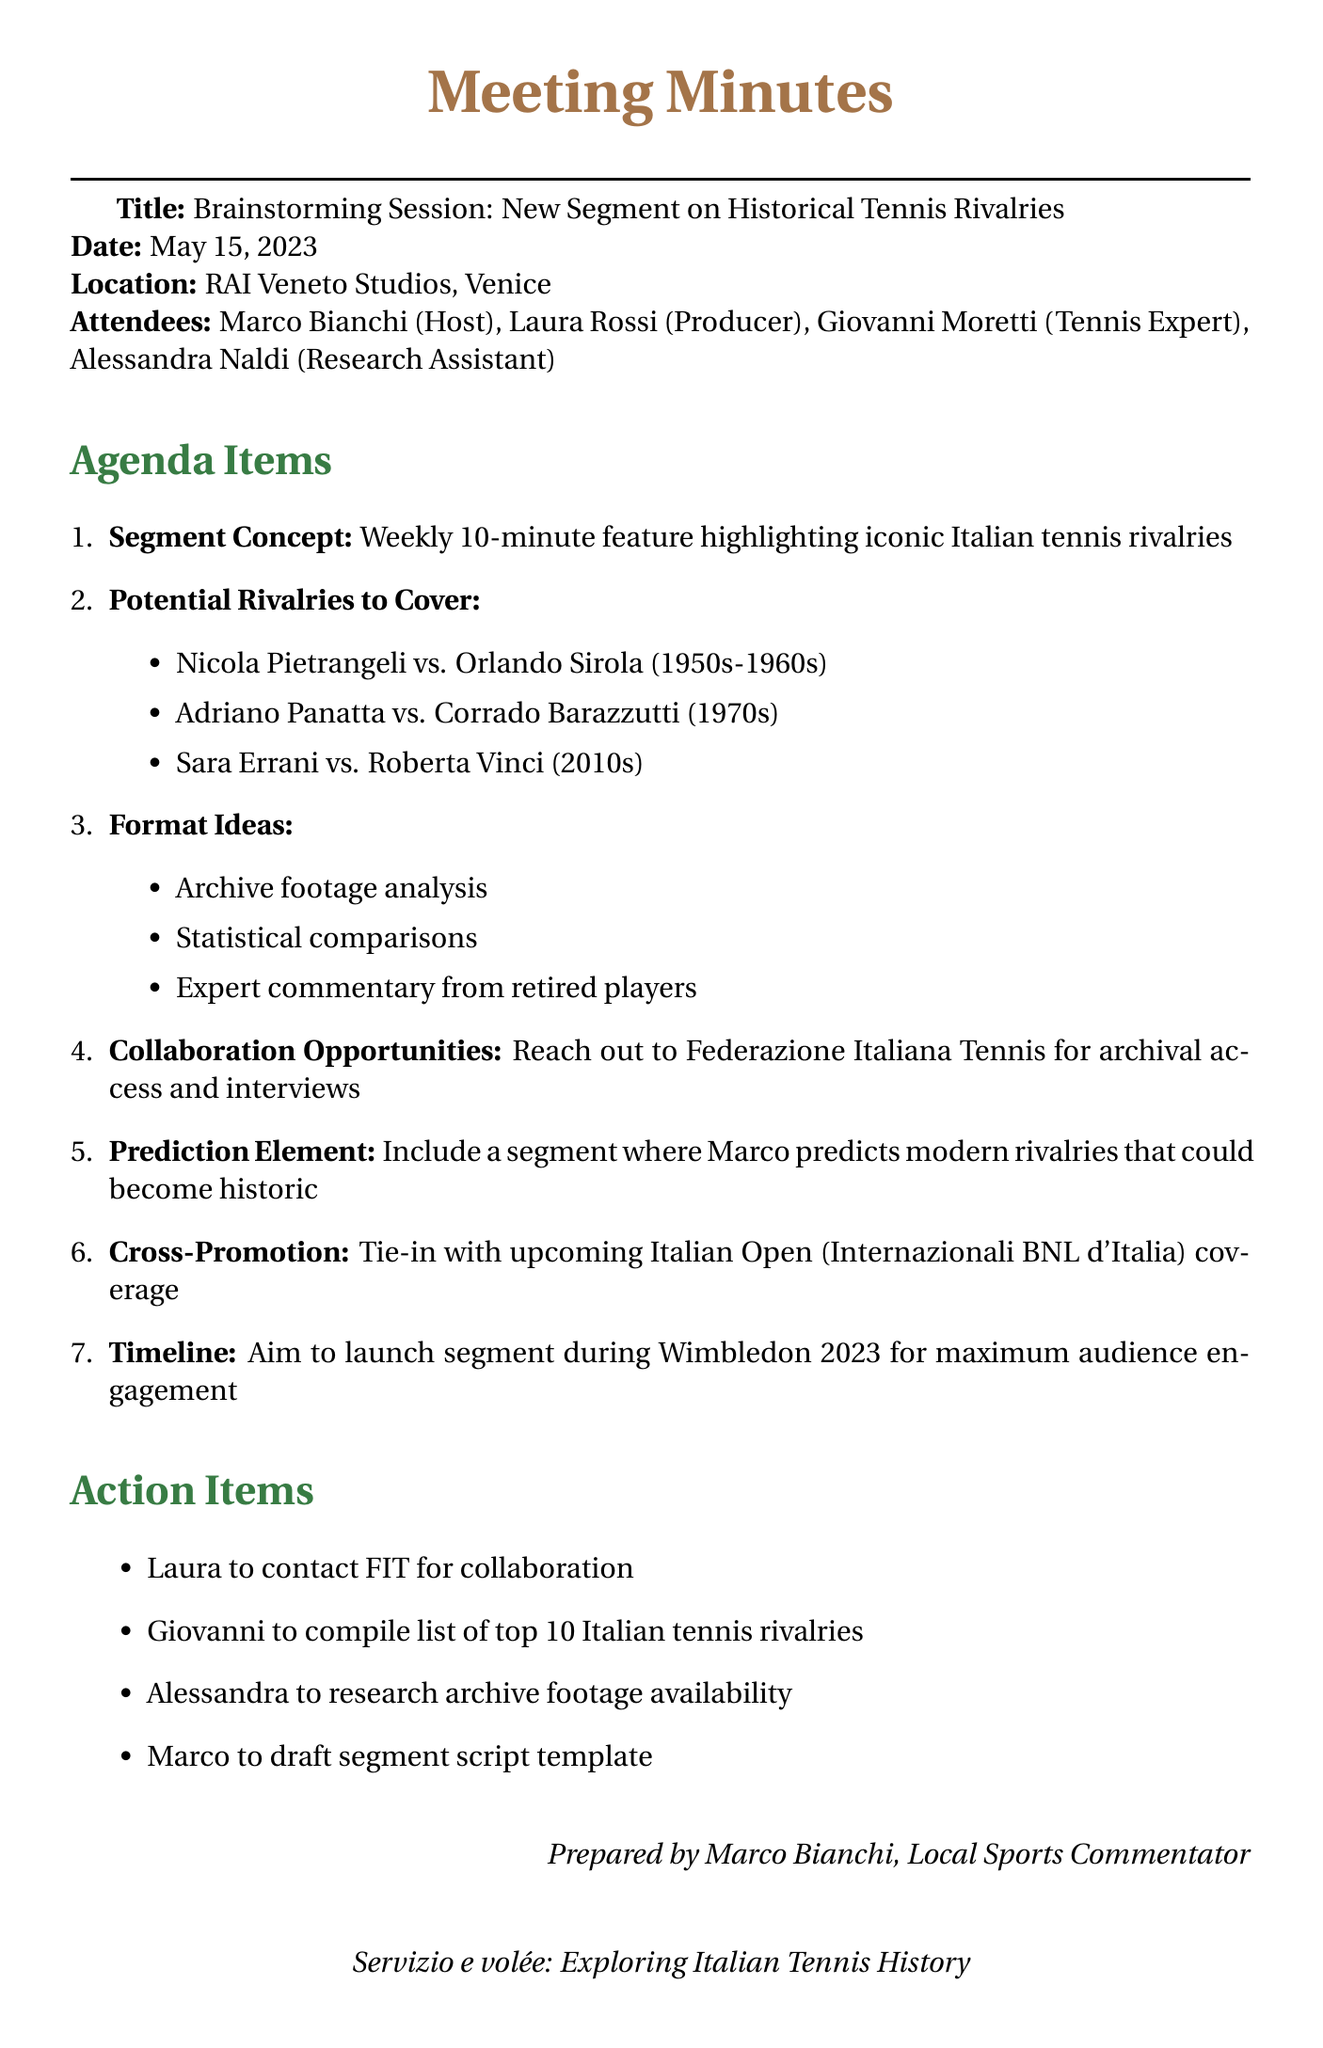what is the title of the meeting? The title of the meeting is explicitly mentioned in the document as "Brainstorming Session: New Segment on Historical Tennis Rivalries."
Answer: Brainstorming Session: New Segment on Historical Tennis Rivalries who was the host of the meeting? The document lists Marco Bianchi as the host of the meeting.
Answer: Marco Bianchi what is the location of the meeting? The meeting is noted to take place at RAI Veneto Studios in Venice.
Answer: RAI Veneto Studios, Venice what is the timeline for launching the segment? The document states that the aim is to launch the segment during Wimbledon 2023.
Answer: during Wimbledon 2023 how long is the segment planned to be? The details indicate that the segment is planned to be a 10-minute feature.
Answer: 10-minute who will compile the list of top 10 Italian tennis rivalries? Giovanni Moretti is responsible for compiling the list according to the action items.
Answer: Giovanni what type of collaboration is suggested in the meeting? The attendees discussed reaching out to Federazione Italiana Tennis for archival access and interviews as a collaboration opportunity.
Answer: Federazione Italiana Tennis what is one of the format ideas mentioned for the segment? The document includes "Archive footage analysis" as one of the format ideas.
Answer: Archive footage analysis what action item is assigned to Alessandra? Alessandra is tasked with researching archive footage availability according to the action items section.
Answer: research archive footage availability 